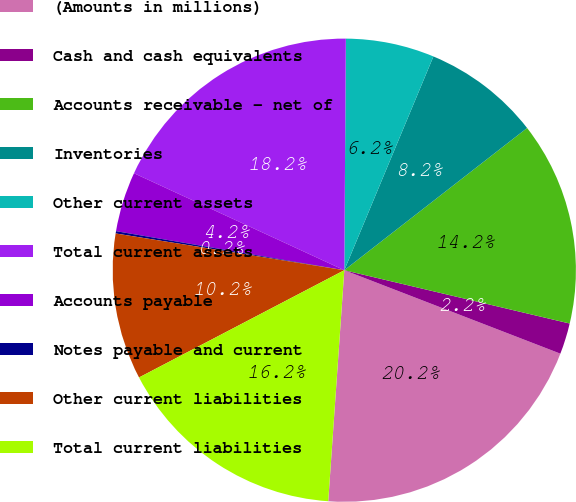<chart> <loc_0><loc_0><loc_500><loc_500><pie_chart><fcel>(Amounts in millions)<fcel>Cash and cash equivalents<fcel>Accounts receivable - net of<fcel>Inventories<fcel>Other current assets<fcel>Total current assets<fcel>Accounts payable<fcel>Notes payable and current<fcel>Other current liabilities<fcel>Total current liabilities<nl><fcel>20.24%<fcel>2.17%<fcel>14.22%<fcel>8.19%<fcel>6.18%<fcel>18.23%<fcel>4.18%<fcel>0.16%<fcel>10.2%<fcel>16.23%<nl></chart> 